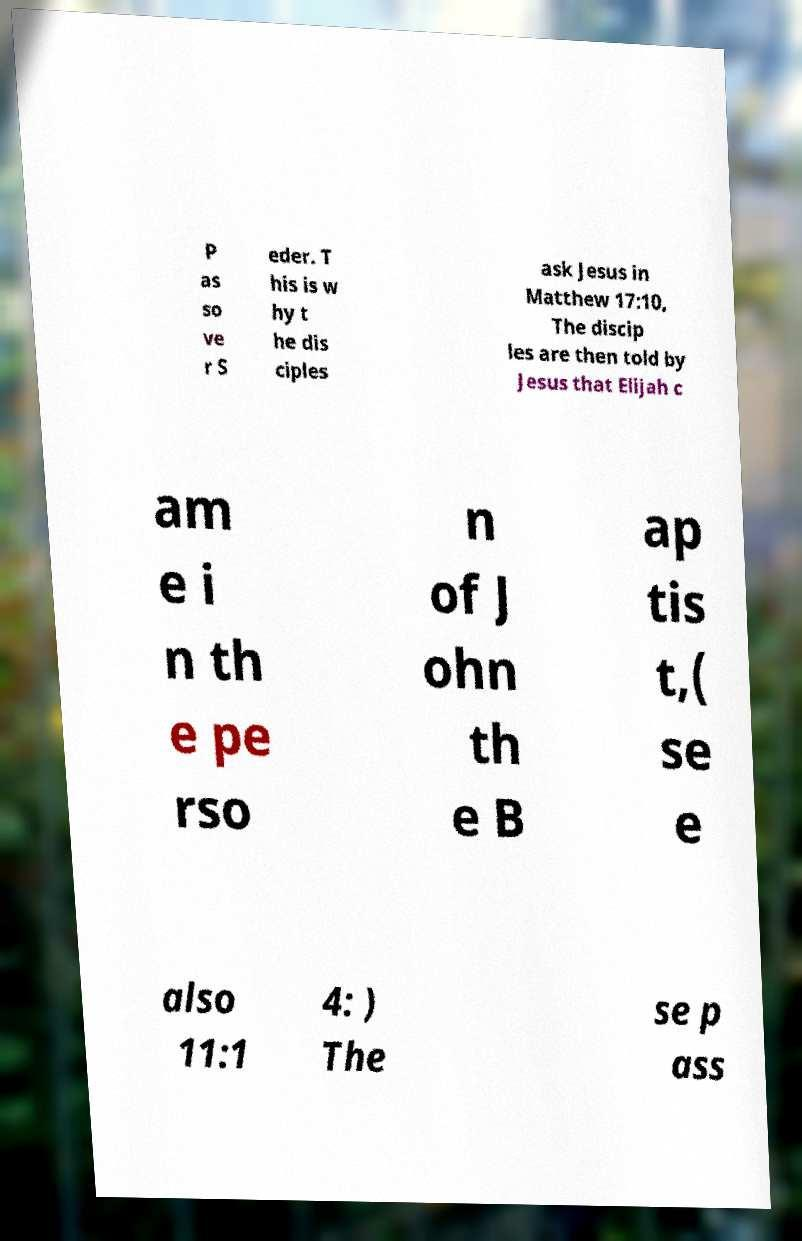There's text embedded in this image that I need extracted. Can you transcribe it verbatim? P as so ve r S eder. T his is w hy t he dis ciples ask Jesus in Matthew 17:10, The discip les are then told by Jesus that Elijah c am e i n th e pe rso n of J ohn th e B ap tis t,( se e also 11:1 4: ) The se p ass 